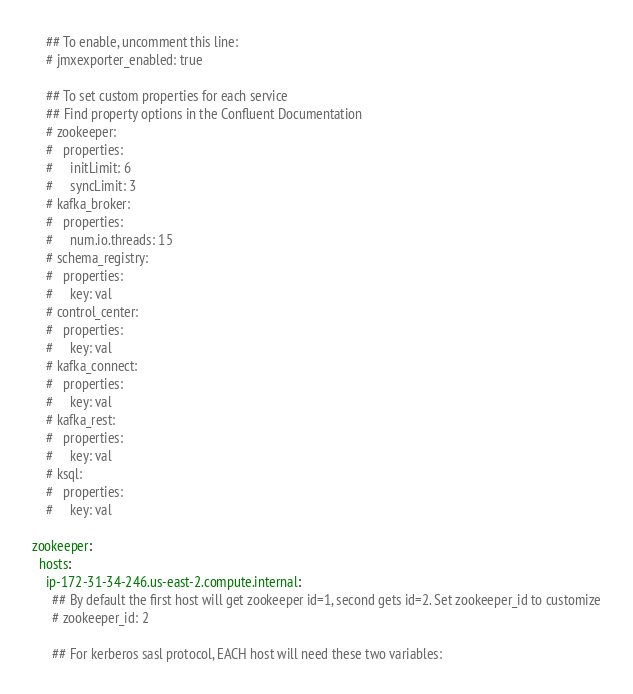Convert code to text. <code><loc_0><loc_0><loc_500><loc_500><_YAML_>    ## To enable, uncomment this line:
    # jmxexporter_enabled: true

    ## To set custom properties for each service
    ## Find property options in the Confluent Documentation
    # zookeeper:
    #   properties:
    #     initLimit: 6
    #     syncLimit: 3
    # kafka_broker:
    #   properties:
    #     num.io.threads: 15
    # schema_registry:
    #   properties:
    #     key: val
    # control_center:
    #   properties:
    #     key: val
    # kafka_connect:
    #   properties:
    #     key: val
    # kafka_rest:
    #   properties:
    #     key: val
    # ksql:
    #   properties:
    #     key: val

zookeeper:
  hosts:
    ip-172-31-34-246.us-east-2.compute.internal:
      ## By default the first host will get zookeeper id=1, second gets id=2. Set zookeeper_id to customize
      # zookeeper_id: 2

      ## For kerberos sasl protocol, EACH host will need these two variables:</code> 